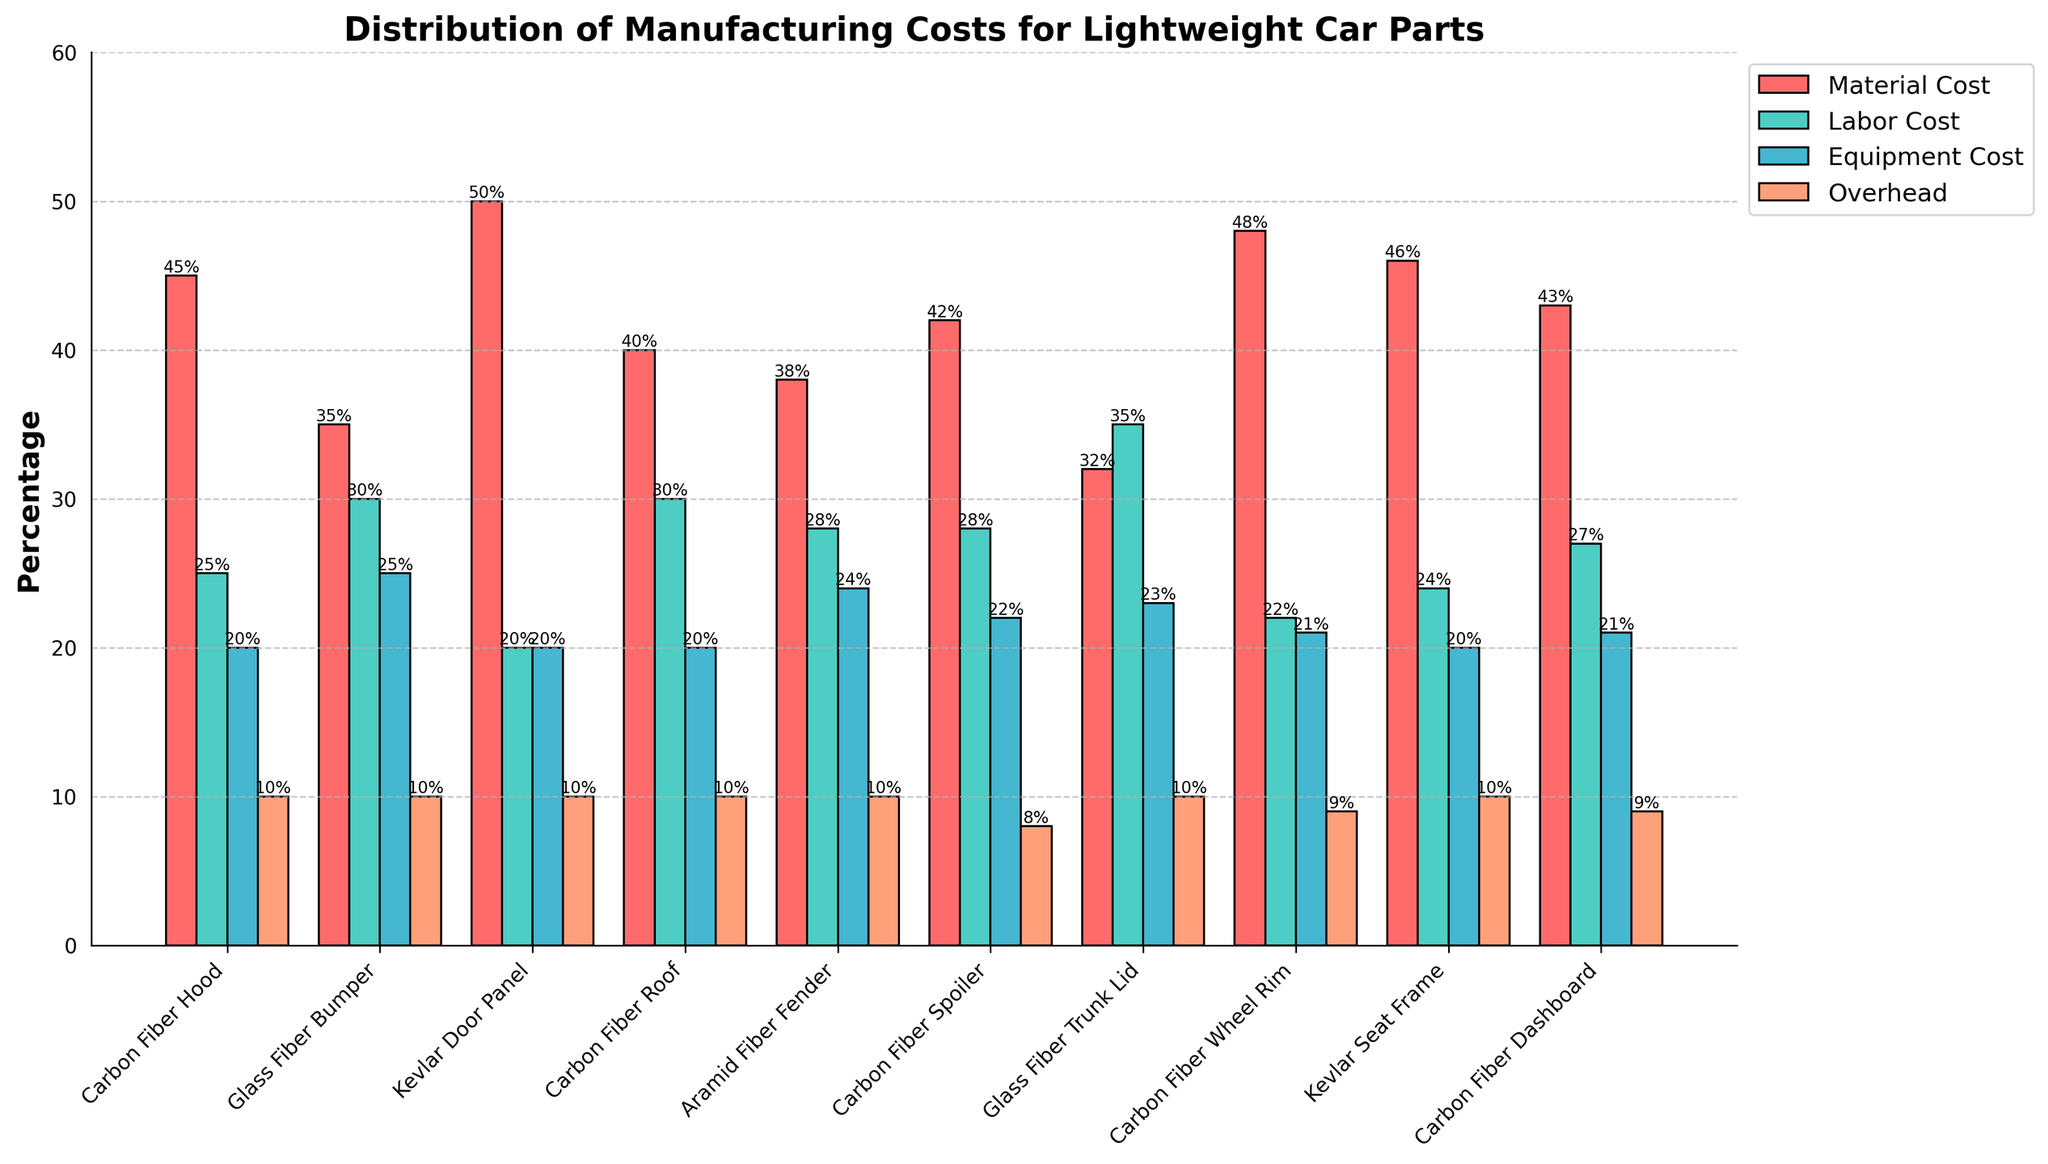Which car part has the highest material cost percentage? Look at the bar representing the material cost for each car part and note the one that reaches the highest point.
Answer: Kevlar Door Panel Compare the labor cost percentage of the Carbon Fiber Dashboard and the Glass Fiber Trunk Lid. Which one is higher? Observe the height of the labor cost bars for the two parts and compare them.
Answer: Glass Fiber Trunk Lid What is the average material cost percentage for all the car parts? Add up all the material cost percentages and divide by the number of car parts: (45 + 35 + 50 + 40 + 38 + 42 + 32 + 48 + 46 + 43) / 10.
Answer: 41.9 Which car part has the lowest overhead cost percentage? All overhead cost percentages are listed as 10% except for the Carbon Fiber Spoiler, which is 8%.
Answer: Carbon Fiber Spoiler How much higher is the equipment cost percentage for the Carbon Fiber Hood compared to the Kevlar Door Panel? Subtract the equipment cost percentage of the Kevlar Door Panel (20%) from that of the Carbon Fiber Hood (20%) to find the difference.
Answer: 0% What is the total cost percentage for labor and overhead for the Carbon Fiber Roof? Sum the labor cost percentage (30%) and the overhead cost percentage (10%) for the Carbon Fiber Roof.
Answer: 40% Compare the material and labor cost percentages for the Aramid Fiber Fender. Which cost is higher, and by how much? Subtract the labor cost percentage (28%) from the material cost percentage (38%) to find the difference.
Answer: Material cost is higher by 10% How does the equipment cost for the Carbon Fiber Wheel Rim compare with the Carbon Fiber Roof? Look at the equipment cost bars for both parts and compare their heights: Carbon Fiber Roof (20%) and Carbon Fiber Wheel Rim (21%).
Answer: Carbon Fiber Wheel Rim is higher by 1% What is the combined cost percentage of equipment and overhead for the Glass Fiber Bumper? Add the equipment cost percentage (25%) and overhead cost percentage (10%) for the Glass Fiber Bumper.
Answer: 35% Which car part has the most balanced distribution of costs across the four categories? Look for the part where the bars for material, labor, equipment, and overhead are most similar in height to each other.
Answer: Kevlar Door Panel 